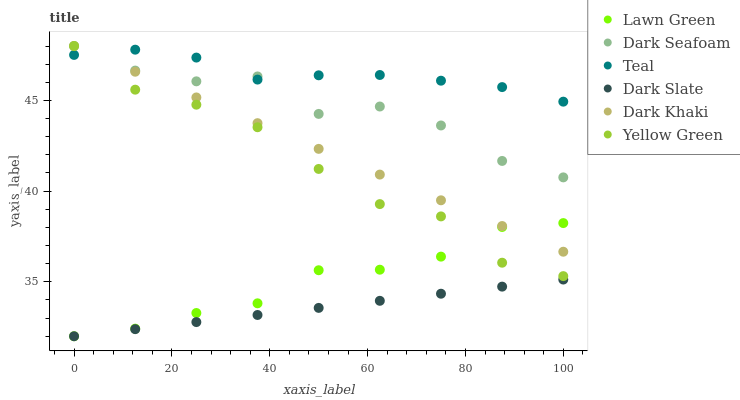Does Dark Slate have the minimum area under the curve?
Answer yes or no. Yes. Does Teal have the maximum area under the curve?
Answer yes or no. Yes. Does Yellow Green have the minimum area under the curve?
Answer yes or no. No. Does Yellow Green have the maximum area under the curve?
Answer yes or no. No. Is Dark Khaki the smoothest?
Answer yes or no. Yes. Is Dark Seafoam the roughest?
Answer yes or no. Yes. Is Yellow Green the smoothest?
Answer yes or no. No. Is Yellow Green the roughest?
Answer yes or no. No. Does Lawn Green have the lowest value?
Answer yes or no. Yes. Does Yellow Green have the lowest value?
Answer yes or no. No. Does Dark Seafoam have the highest value?
Answer yes or no. Yes. Does Dark Slate have the highest value?
Answer yes or no. No. Is Lawn Green less than Dark Seafoam?
Answer yes or no. Yes. Is Yellow Green greater than Dark Slate?
Answer yes or no. Yes. Does Dark Seafoam intersect Dark Khaki?
Answer yes or no. Yes. Is Dark Seafoam less than Dark Khaki?
Answer yes or no. No. Is Dark Seafoam greater than Dark Khaki?
Answer yes or no. No. Does Lawn Green intersect Dark Seafoam?
Answer yes or no. No. 